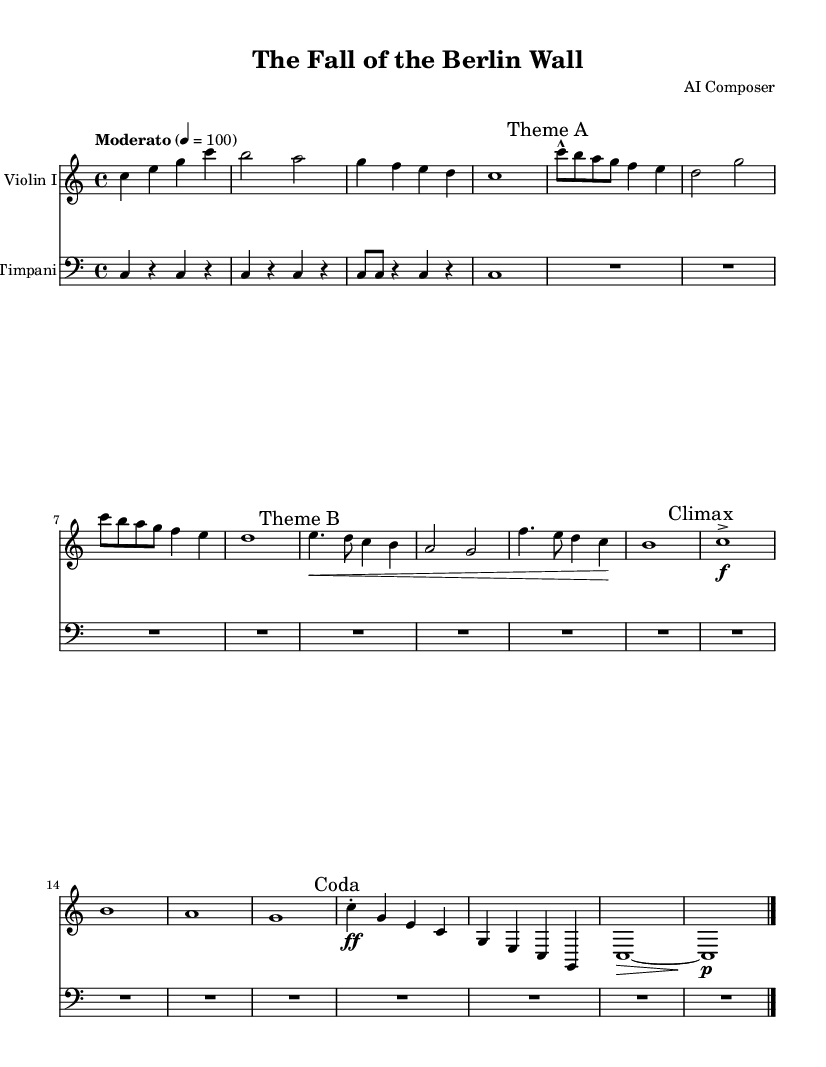What is the key signature of this music? The key signature indicates the notes that are sharp or flat in a piece of music. In this piece, there are no sharps or flats, which corresponds to C major.
Answer: C major What is the time signature of this music? The time signature tells us how many beats are in each measure. This music has a time signature of 4/4, meaning there are four beats in each measure and the quarter note gets one beat.
Answer: 4/4 What is the tempo marking of this piece? The tempo marking indicates the speed of the music. The piece is marked "Moderato," which generally means a moderate speed, and it is tempo marked at 100 beats per minute.
Answer: Moderato What are the two themes labeled in the music? The music contains two distinct themes indicated in the score. The first theme is labeled "Theme A" and the second one is labeled "Theme B." These labels help in identifying different musical ideas presented in the piece.
Answer: Theme A, Theme B What dynamics are noted during the climax of the piece? The climax of the piece is marked with a dynamic indication of "f," which stands for forte, meaning it should be played loudly. This section builds intensity within the piece.
Answer: f How many measures are in the introduction section? The introduction consists of a specific number of measures that set the stage for the piece. Counting the measures written in the introduction section, there are six measures in total.
Answer: 6 What instrument plays the main melody in this score? The main melody is typically highlighted by a specific instrument in orchestral pieces. In this score, the violin plays the primary melodic lines, as indicated by the instrument name above the staff.
Answer: Violin I 